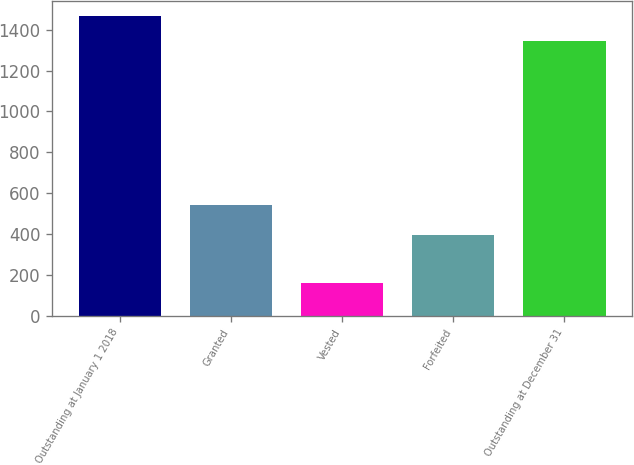Convert chart. <chart><loc_0><loc_0><loc_500><loc_500><bar_chart><fcel>Outstanding at January 1 2018<fcel>Granted<fcel>Vested<fcel>Forfeited<fcel>Outstanding at December 31<nl><fcel>1467.1<fcel>542<fcel>160<fcel>396<fcel>1347<nl></chart> 